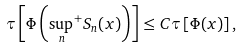Convert formula to latex. <formula><loc_0><loc_0><loc_500><loc_500>\tau \left [ \Phi \left ( { \sup _ { n } } ^ { + } S _ { n } ( x ) \right ) \right ] \leq C \tau \left [ \Phi ( x ) \right ] ,</formula> 